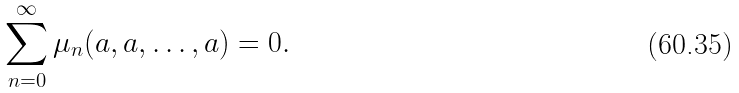Convert formula to latex. <formula><loc_0><loc_0><loc_500><loc_500>\sum _ { n = 0 } ^ { \infty } \mu _ { n } ( a , a , \dots , a ) = 0 .</formula> 